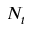Convert formula to latex. <formula><loc_0><loc_0><loc_500><loc_500>N _ { t }</formula> 